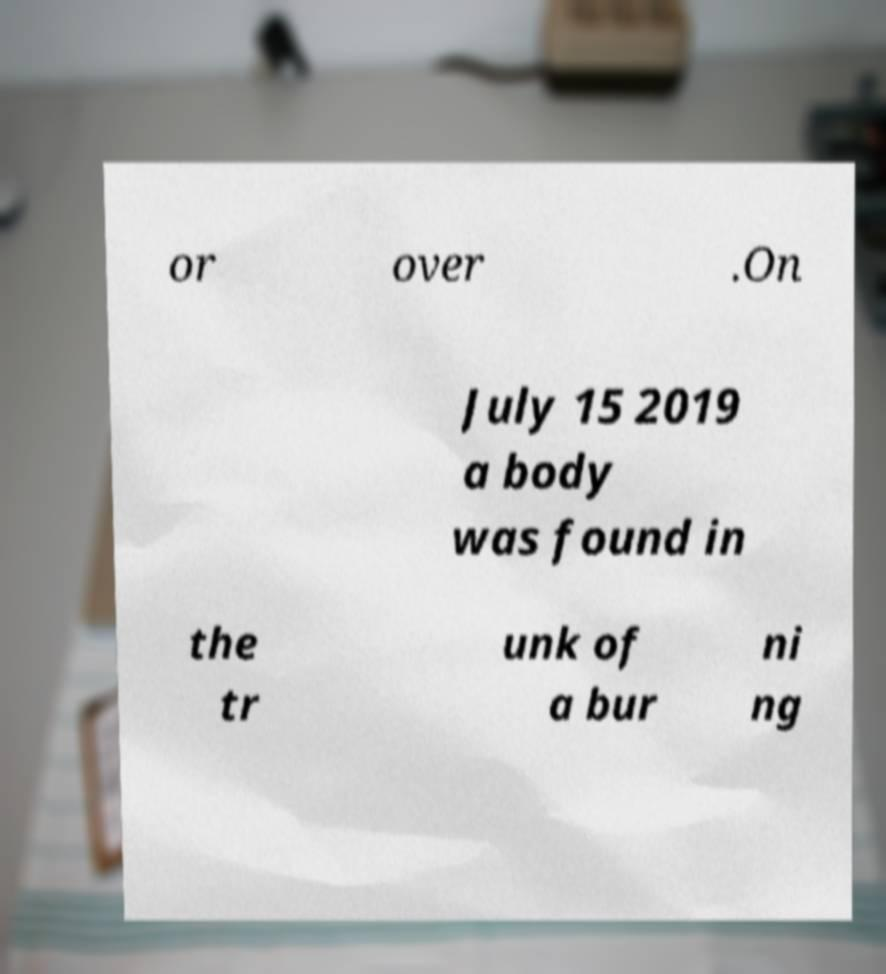Could you assist in decoding the text presented in this image and type it out clearly? or over .On July 15 2019 a body was found in the tr unk of a bur ni ng 